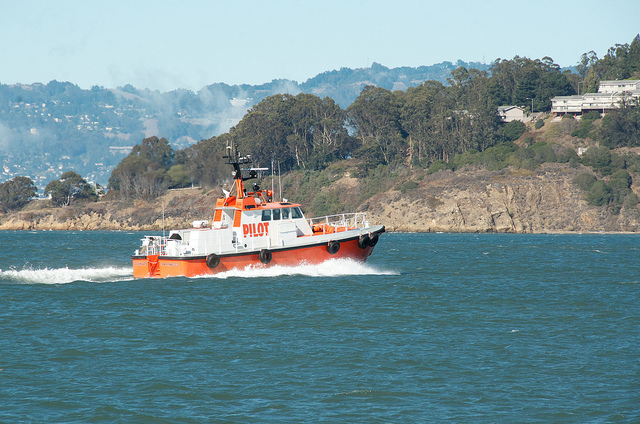Please transcribe the text information in this image. PILOT 